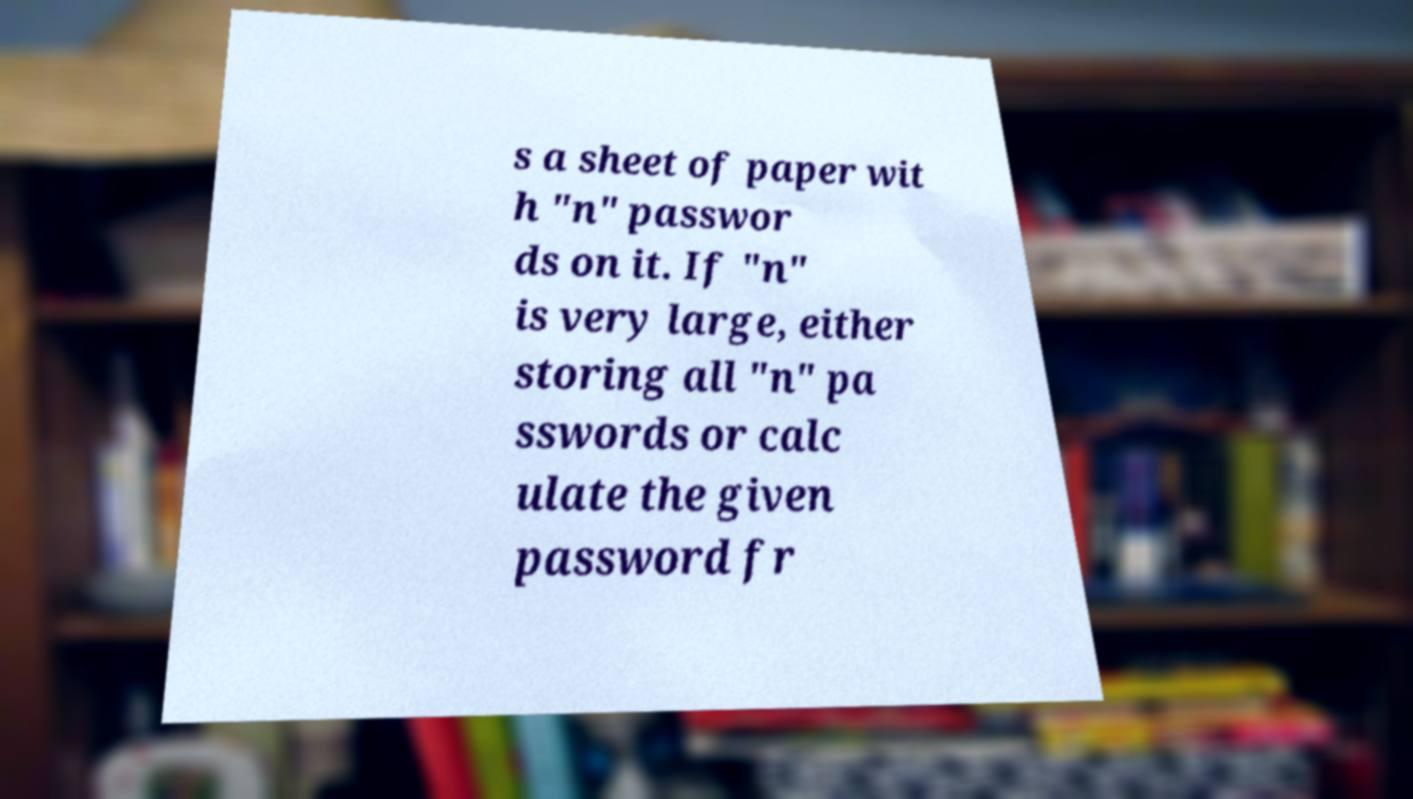For documentation purposes, I need the text within this image transcribed. Could you provide that? s a sheet of paper wit h "n" passwor ds on it. If "n" is very large, either storing all "n" pa sswords or calc ulate the given password fr 